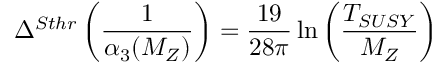Convert formula to latex. <formula><loc_0><loc_0><loc_500><loc_500>\Delta ^ { S t h r } \left ( \frac { 1 } { \alpha _ { 3 } ( M _ { Z } ) } \right ) = \frac { 1 9 } { 2 8 \pi } \ln \left ( \frac { T _ { S U S Y } } { M _ { Z } } \right )</formula> 